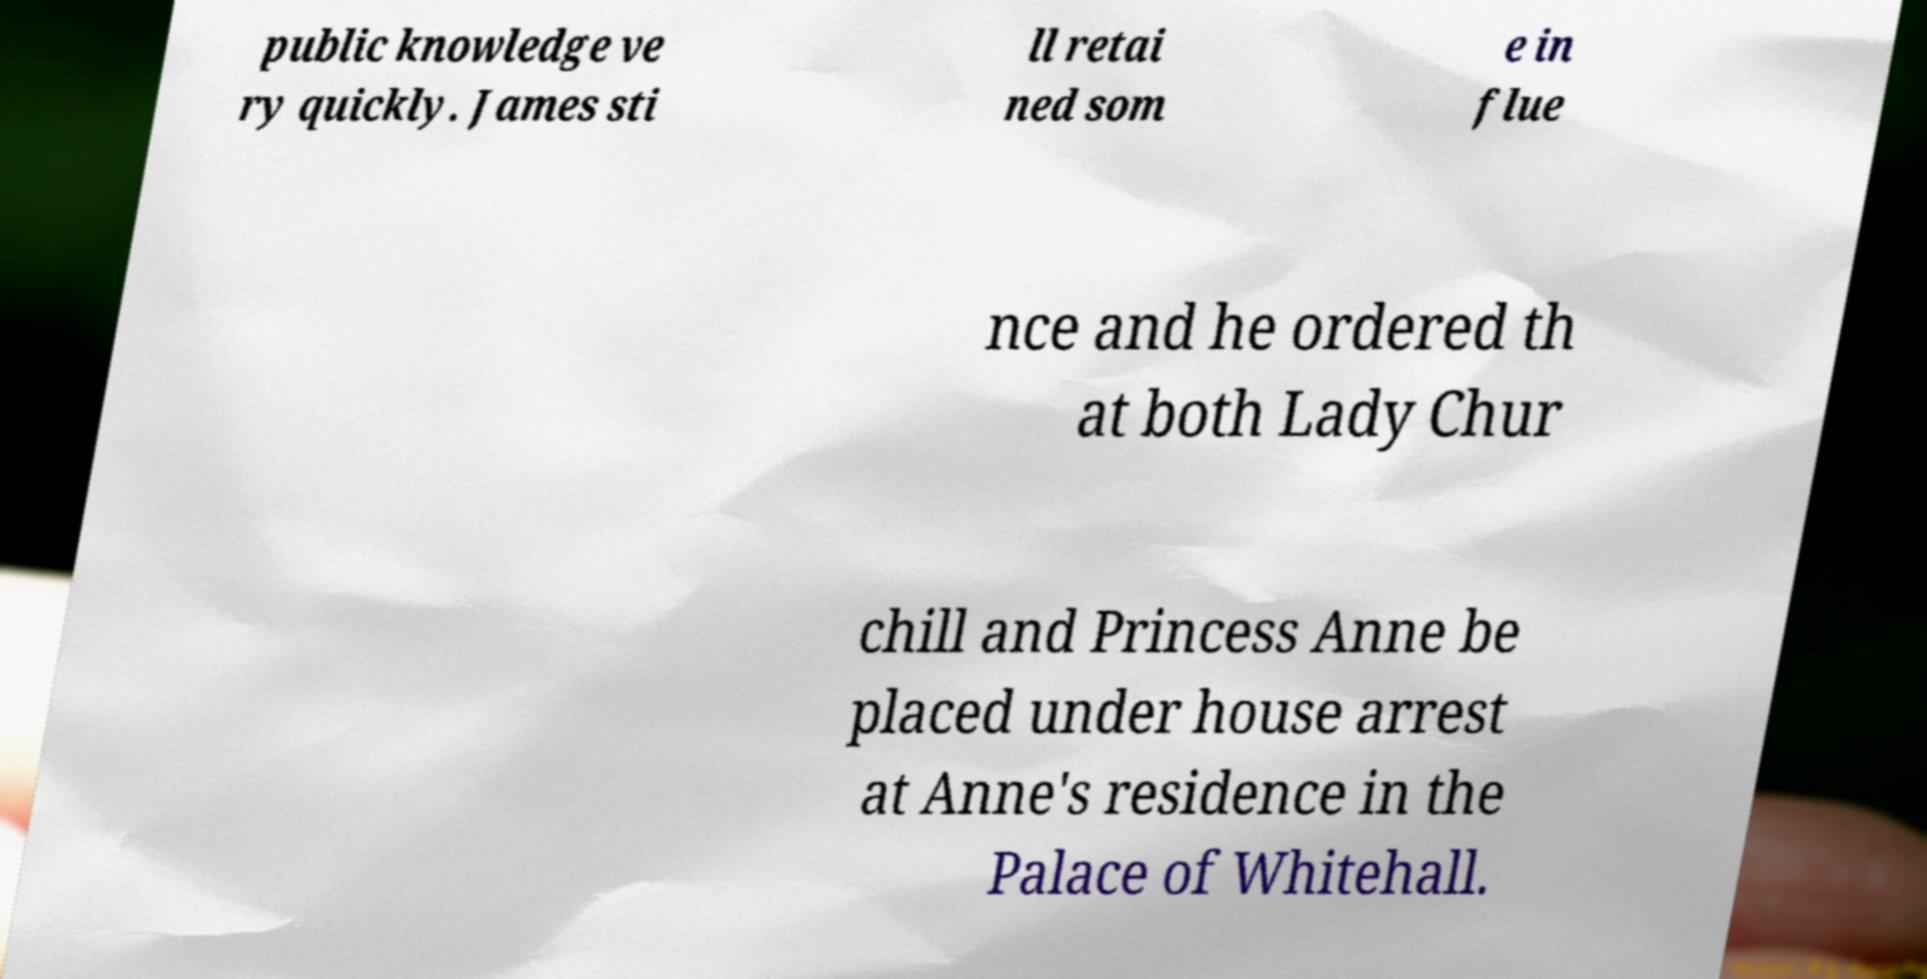Could you assist in decoding the text presented in this image and type it out clearly? public knowledge ve ry quickly. James sti ll retai ned som e in flue nce and he ordered th at both Lady Chur chill and Princess Anne be placed under house arrest at Anne's residence in the Palace of Whitehall. 